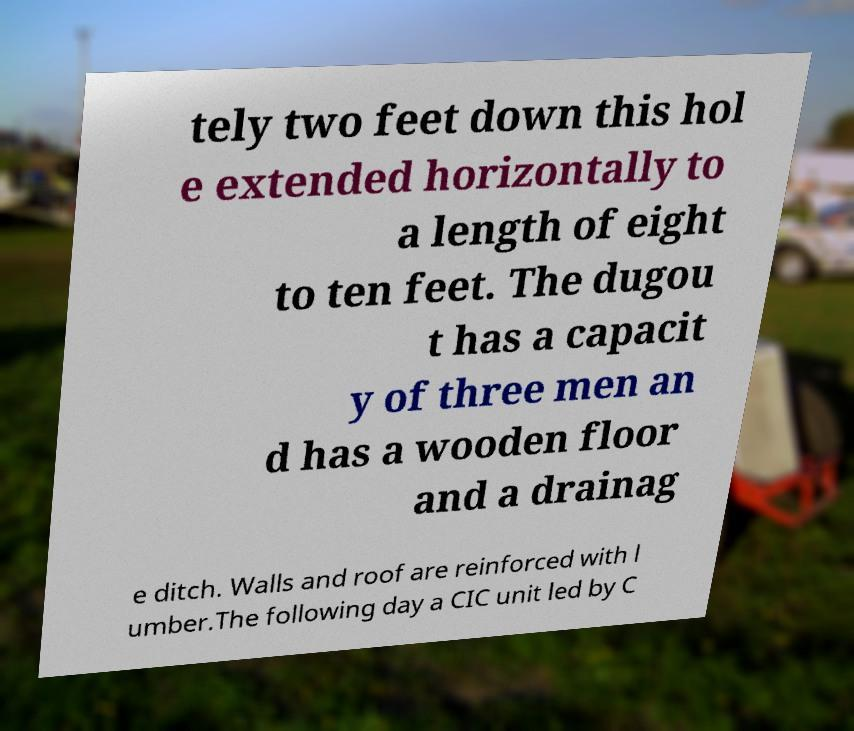Could you extract and type out the text from this image? tely two feet down this hol e extended horizontally to a length of eight to ten feet. The dugou t has a capacit y of three men an d has a wooden floor and a drainag e ditch. Walls and roof are reinforced with l umber.The following day a CIC unit led by C 